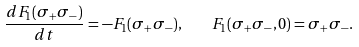Convert formula to latex. <formula><loc_0><loc_0><loc_500><loc_500>\frac { d F _ { 1 } ( \sigma _ { + } \sigma _ { - } ) } { d t } = - F _ { 1 } ( \sigma _ { + } \sigma _ { - } ) , \quad F _ { 1 } ( \sigma _ { + } \sigma _ { - } , 0 ) = \sigma _ { + } \sigma _ { - } .</formula> 